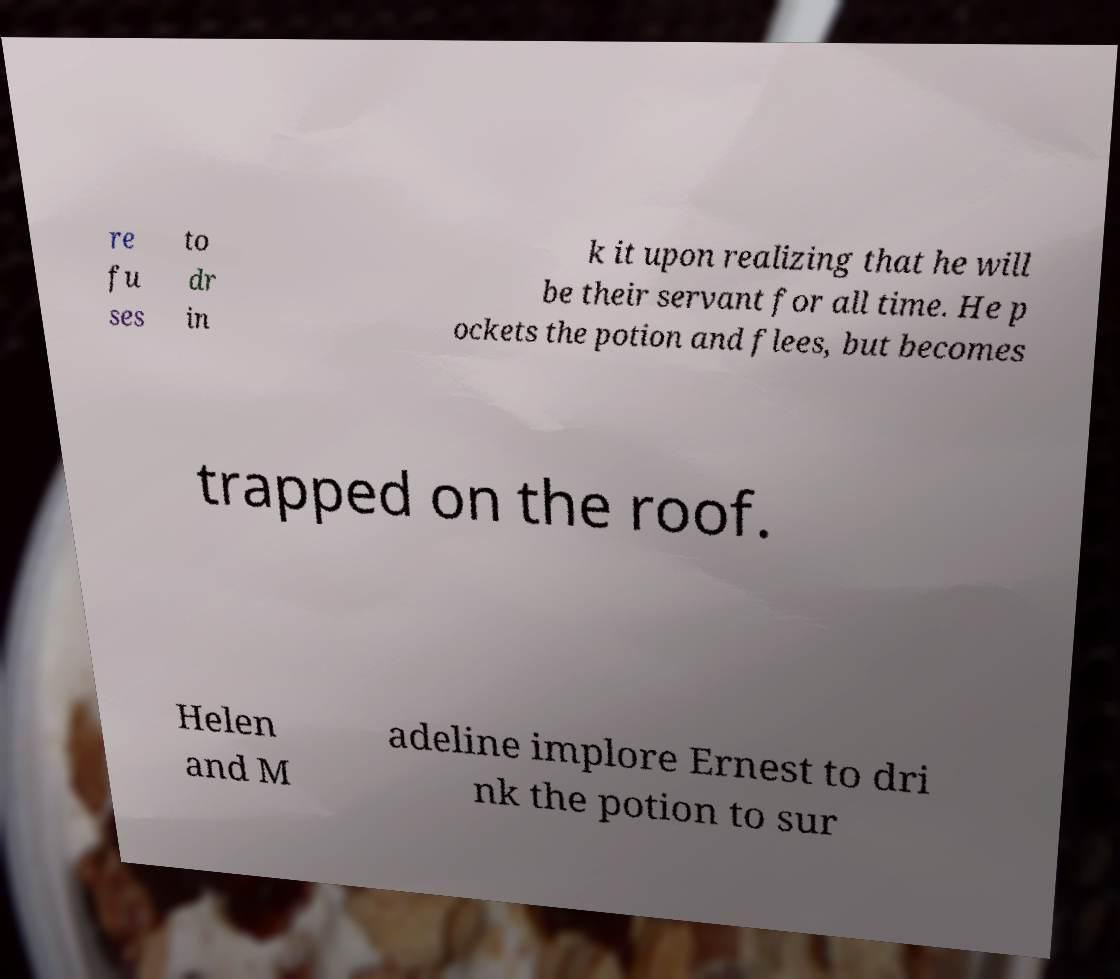Could you assist in decoding the text presented in this image and type it out clearly? re fu ses to dr in k it upon realizing that he will be their servant for all time. He p ockets the potion and flees, but becomes trapped on the roof. Helen and M adeline implore Ernest to dri nk the potion to sur 